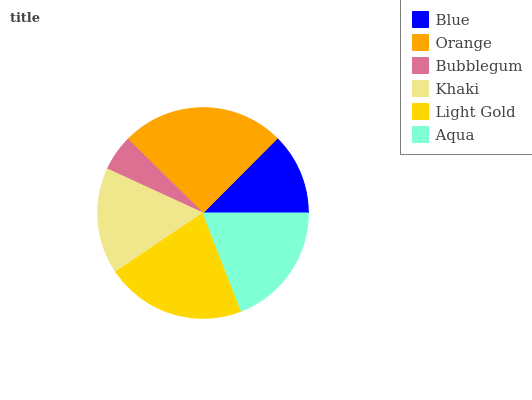Is Bubblegum the minimum?
Answer yes or no. Yes. Is Orange the maximum?
Answer yes or no. Yes. Is Orange the minimum?
Answer yes or no. No. Is Bubblegum the maximum?
Answer yes or no. No. Is Orange greater than Bubblegum?
Answer yes or no. Yes. Is Bubblegum less than Orange?
Answer yes or no. Yes. Is Bubblegum greater than Orange?
Answer yes or no. No. Is Orange less than Bubblegum?
Answer yes or no. No. Is Aqua the high median?
Answer yes or no. Yes. Is Khaki the low median?
Answer yes or no. Yes. Is Blue the high median?
Answer yes or no. No. Is Aqua the low median?
Answer yes or no. No. 